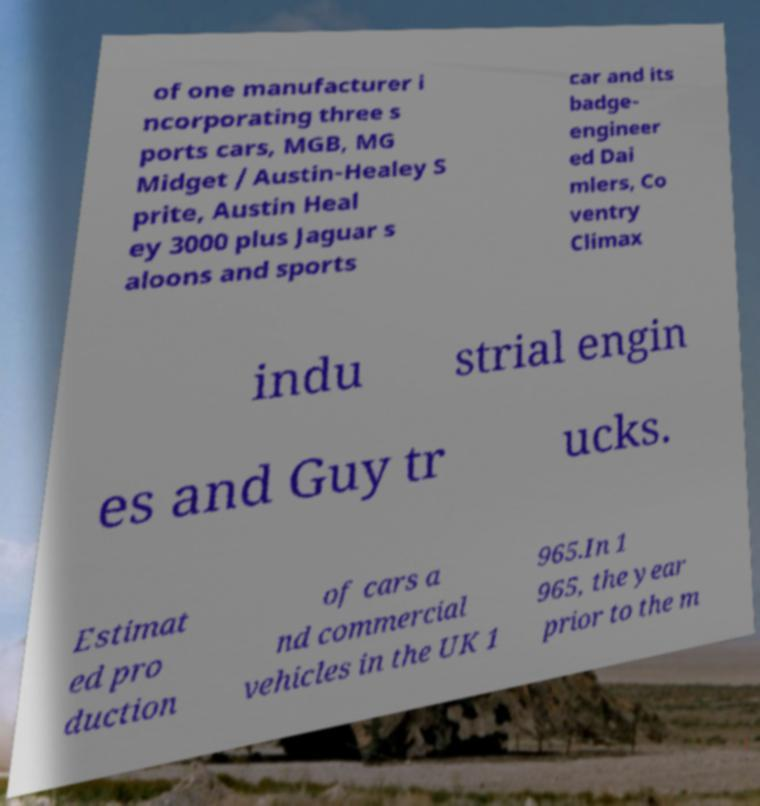Could you assist in decoding the text presented in this image and type it out clearly? of one manufacturer i ncorporating three s ports cars, MGB, MG Midget / Austin-Healey S prite, Austin Heal ey 3000 plus Jaguar s aloons and sports car and its badge- engineer ed Dai mlers, Co ventry Climax indu strial engin es and Guy tr ucks. Estimat ed pro duction of cars a nd commercial vehicles in the UK 1 965.In 1 965, the year prior to the m 